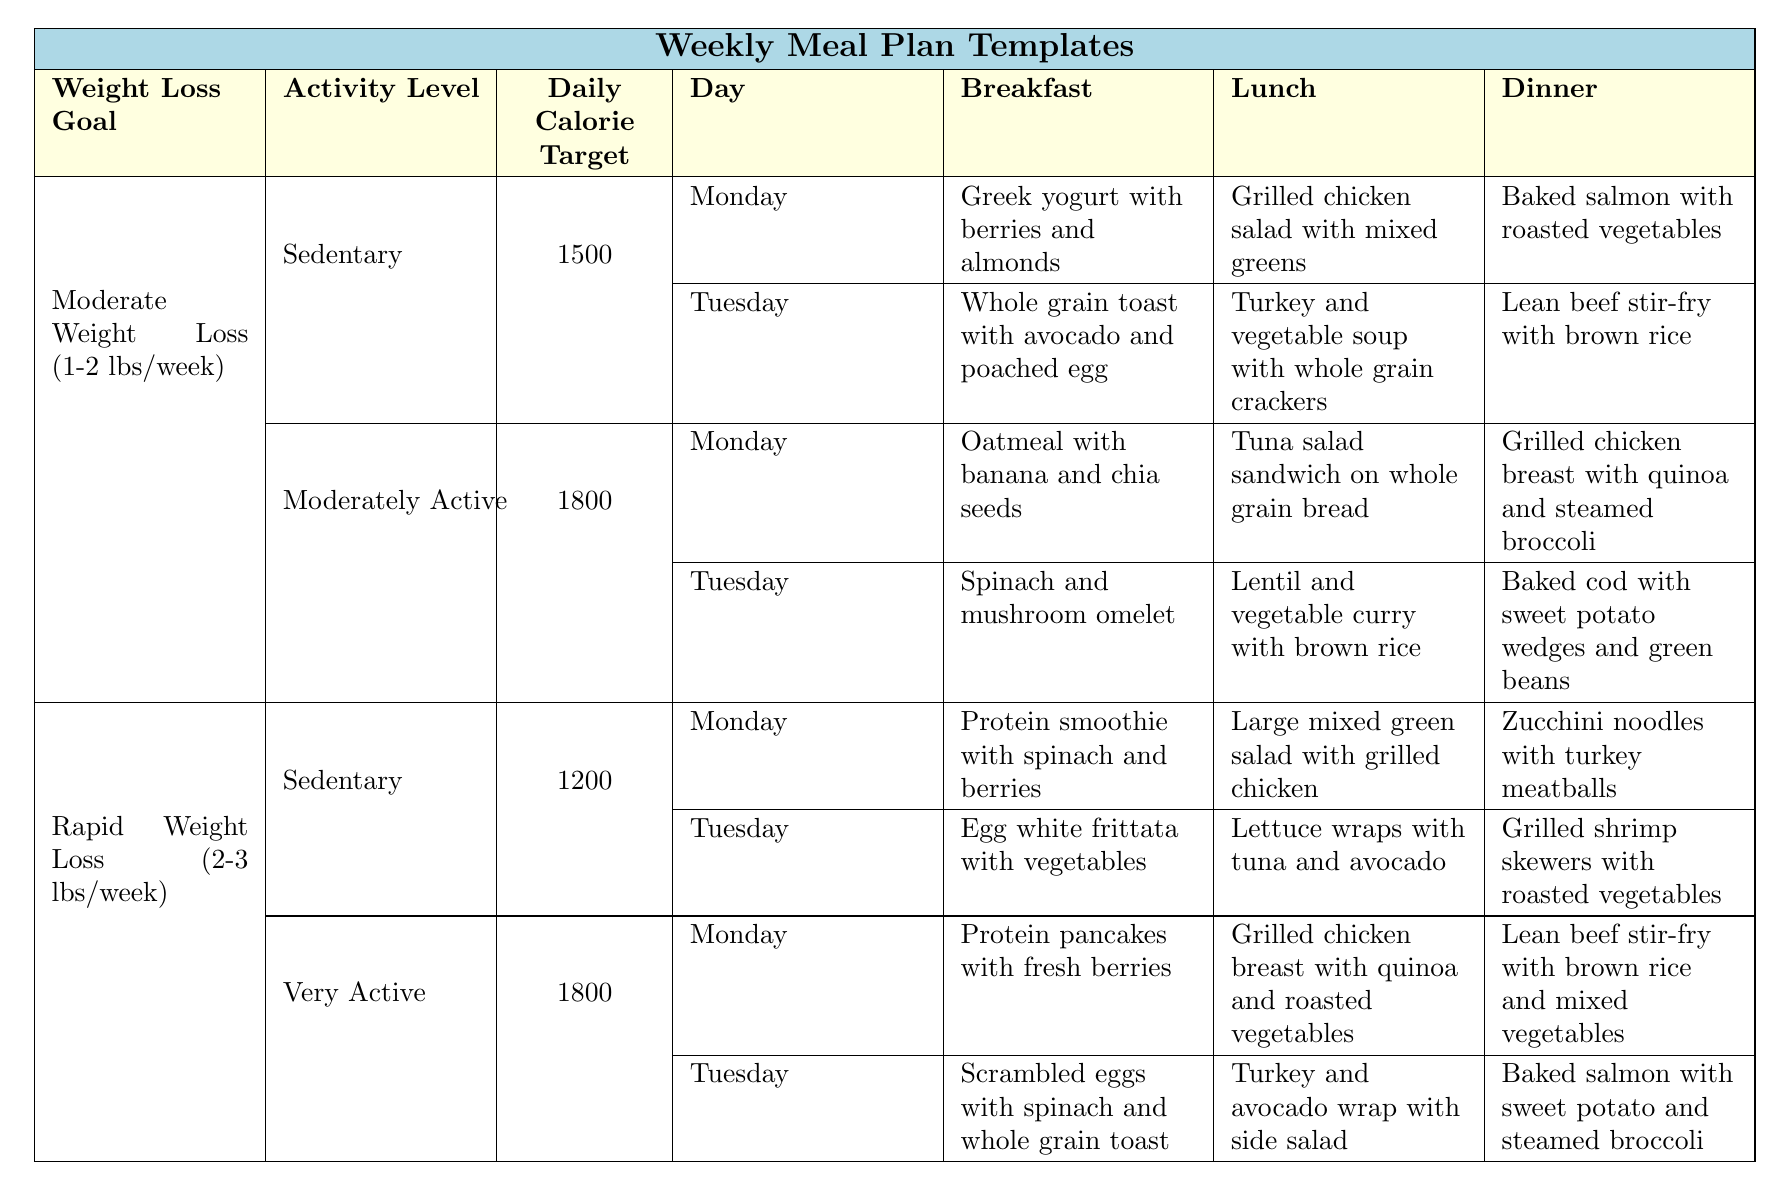What is the daily calorie target for a sedentary individual aiming for moderate weight loss? The table indicates that the daily calorie target for a sedentary individual with the goal of moderate weight loss is listed in the corresponding cell, which is 1500 calories.
Answer: 1500 What meal is scheduled for lunch on Tuesday for someone aiming for rapid weight loss and being sedentary? By checking the "Rapid Weight Loss (2-3 lbs/week)" section for the "Sedentary" activity level, the table shows that the lunch on Tuesday is "Lettuce wraps with tuna and avocado."
Answer: Lettuce wraps with tuna and avocado What is the total daily calorie target for a moderately active individual seeking moderate weight loss? The calorie target for a moderately active individual under the moderate weight loss goal is found in the respective section of the table, which totals to 1800 calories per day.
Answer: 1800 Is breakfast on Monday the same for both weight loss goals at the sedentary activity level? The table shows that for moderate weight loss, the breakfast on Monday is "Greek yogurt with berries and almonds," while for rapid weight loss it is "Protein smoothie with spinach and berries," thus they are not the same.
Answer: No Which dinner option has a sweet potato included for someone who is very active and aiming for rapid weight loss? Looking at the "Very Active" section under the "Rapid Weight Loss (2-3 lbs/week)" goal on Monday, the dinner is "Baked salmon with sweet potato and steamed broccoli," indicating sweet potato is included.
Answer: Baked salmon with sweet potato and steamed broccoli How many unique snack options are there for the meals listed? By reviewing the snack options for each meal plan, I counted them as follows: snacks for moderate weight loss include 4 unique items and those for rapid weight loss include an additional 4 unique items, totaling 8 unique snack options.
Answer: 8 On Tuesday, what is the difference in calorie targets between moderately active individuals aiming for moderate weight loss and sedentary individuals aiming for rapid weight loss? The calorie target for moderately active with moderate weight loss is 1800 and for sedentary with rapid weight loss is 1200. The difference is calculated as 1800 - 1200 = 600 calories.
Answer: 600 For both weight loss goals, what is the total number of breakfast options available in the meal plans? The table shows there are 4 breakfast options for moderate weight loss and 4 options for rapid weight loss; therefore, we sum these to get a total of 8 unique breakfast options available across both categories.
Answer: 8 What is the most common protein source for dinner in the plans? By analyzing the dinner options in each section, salmon appears twice as a protein source and is the most frequently mentioned. Other proteins include chicken, turkey, and shrimp, but salmon is the most common.
Answer: Salmon Which lunch option includes quinoa for someone who is moderately active aiming for moderate weight loss? The table states that on Monday, the lunch for a moderately active individual is "Tuna salad sandwich on whole grain bread," and on Tuesday, it is "Lentil and vegetable curry with brown rice." Neither of these include quinoa.
Answer: None 